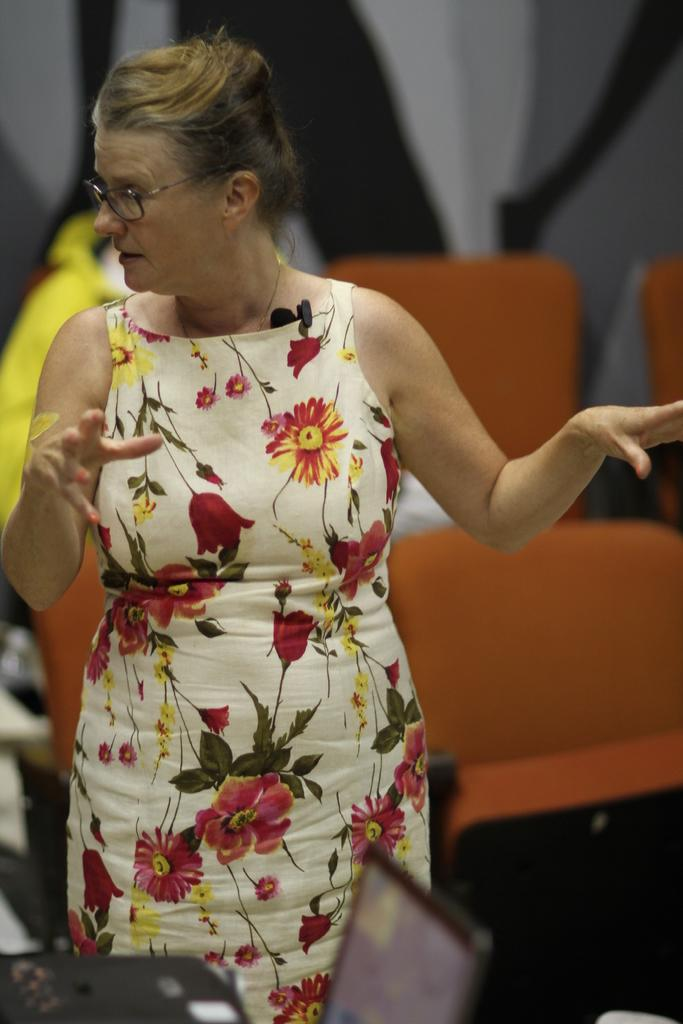What is the setting of the image? The image is likely taken inside a room. Who is the main subject in the image? There is a woman standing in the middle of the image. What is the woman doing in the image? The woman is standing in front of a laptop. What can be seen in the background of the image? There are chairs and persons visible in the background of the image. What type of locket is the woman wearing in the image? There is no locket visible on the woman in the image. What flavor of cake is being served to the persons in the background of the image? There is no cake present in the image; only chairs and persons are visible in the background. 